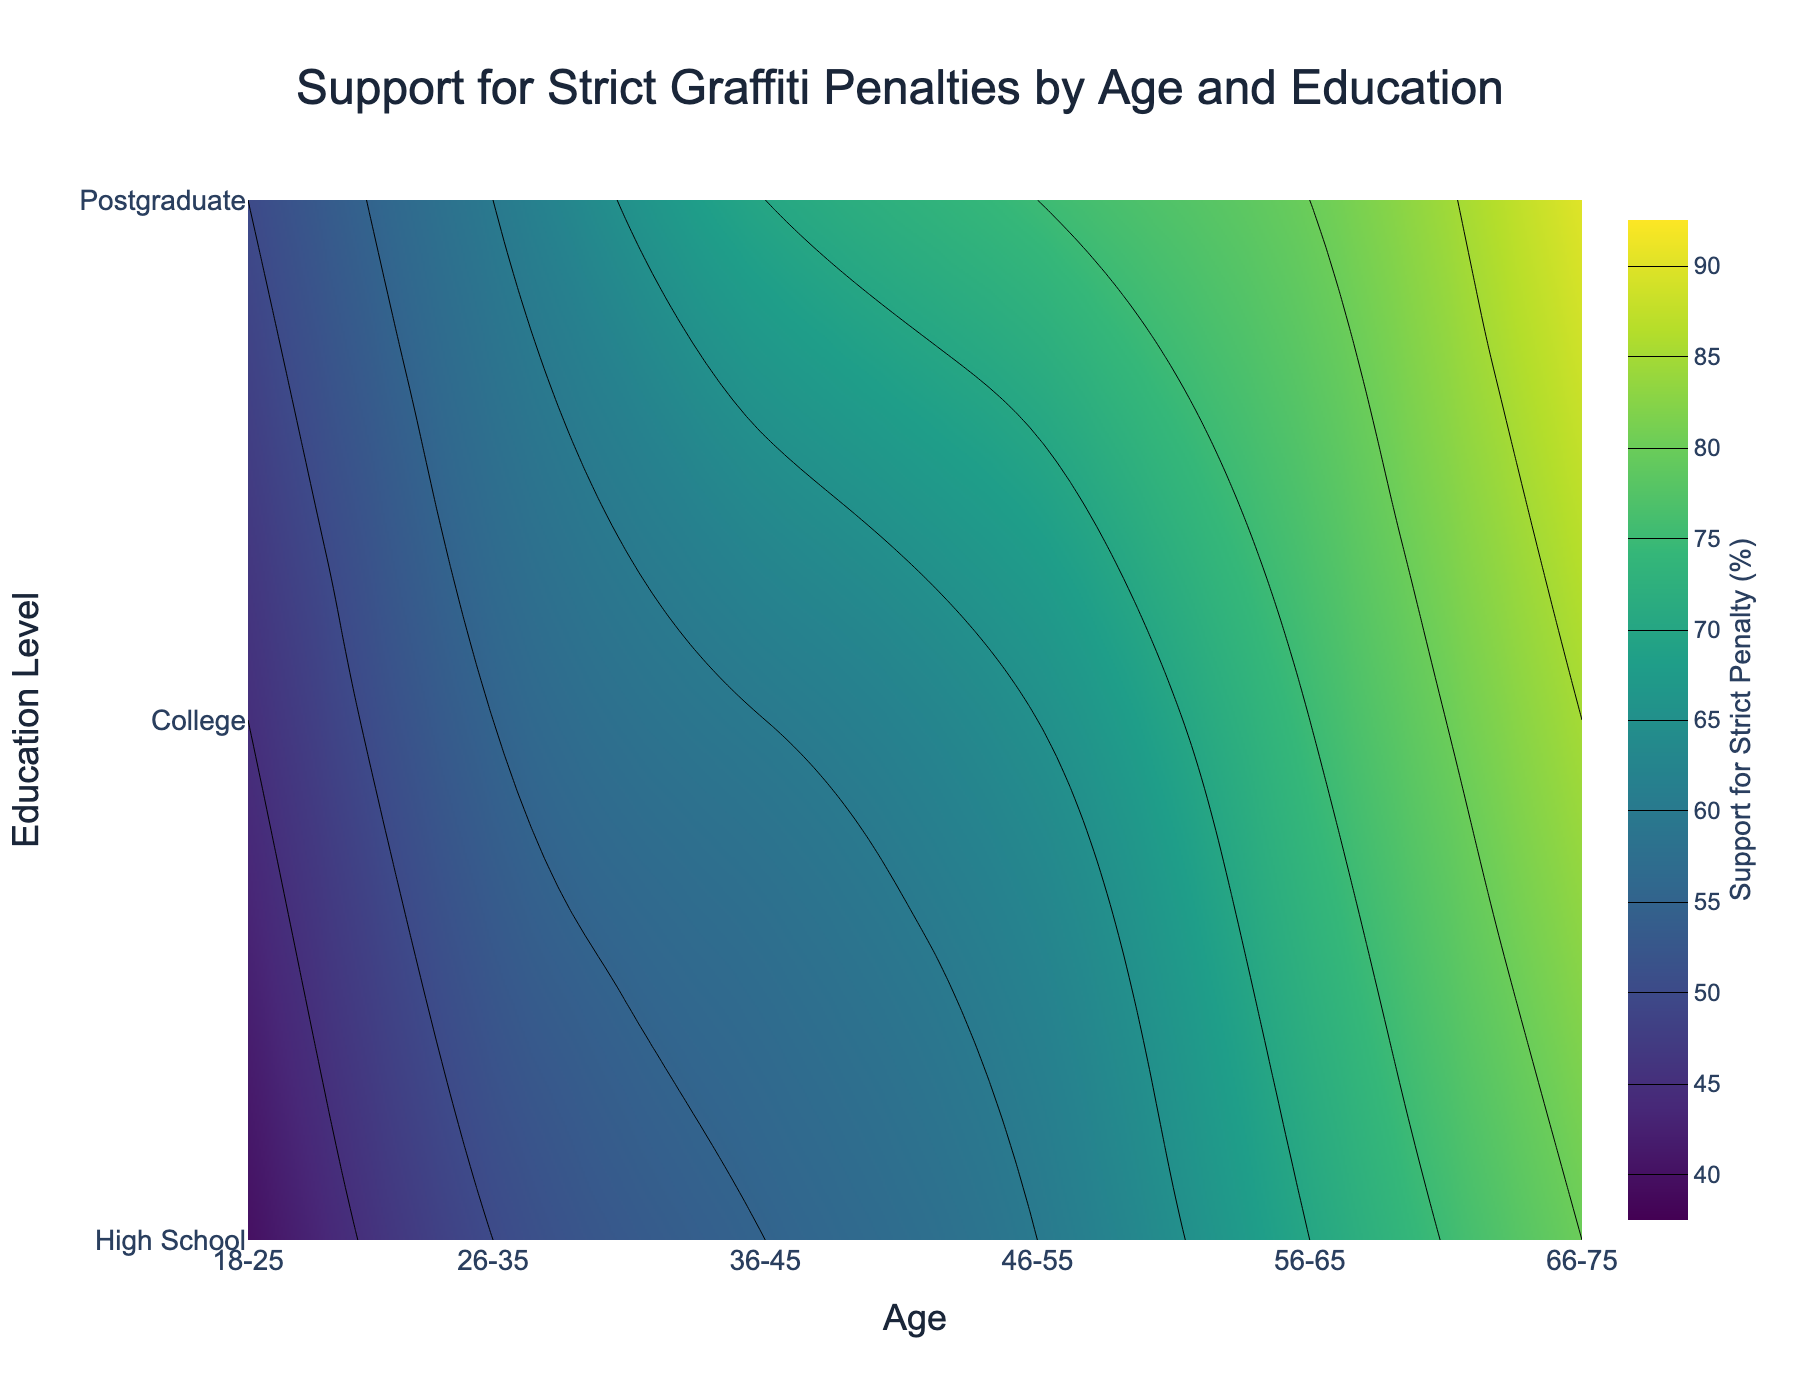What does the title of the plot say? The title is centered at the top of the plot and provides the context for understanding the data. The title text reads "Support for Strict Graffiti Penalties by Age and Education".
Answer: Support for Strict Graffiti Penalties by Age and Education What are the x and y-axis titles? The axes provide labels indicating what dimensions are represented in the contour plot. The x-axis title is "Age", and the y-axis title is "Education Level".
Answer: Age; Education Level Which age group shows the least support for strict graffiti penalties at the High School education level? Observing the contour areas on the left side of the plot, the least support for strict penalties at the High School education level is indicated as the lowest value, present in the age group 18-25.
Answer: 18-25 How does support for strict graffiti penalties change with age at the College education level? Following the contour lines upwards (y=2) as age increases on the x-axis, the contour lines indicate an increase in support percentages. Thus, support for strict penalties generally increases with age at the College education level.
Answer: Increases Compare the support for strict penalties between individuals aged 56-65 with a Postgraduate education to those aged 26-35 with a High School education. Locate the two intersection points on the contour lines: 56-65/Postgraduate and 26-35/High School. The corresponding values show that individuals aged 56-65 with a Postgraduate education show higher support compared to individuals aged 26-35 with a High School education.
Answer: 80 vs. 50 What is the range of support for strict graffiti penalties across different education levels for the age group 36-45? Identify where the age group 36-45 intersects with different education levels and note the corresponding z-values (contour values). The support lies between 55% at High School and 70% at Postgraduate levels.
Answer: 55 to 70% For which age group does the support for strict penalties rise the most from High School to Postgraduate levels? Observing the contour lines across each age group and noting the difference between the lowest and highest support values within each group, the age group 66-75 shows the largest rise, from ~80% to ~90%.
Answer: 66-75 What color range indicates the highest level of support for strict graffiti penalties? Examine the color scale bar on the right side of the plot. The highest support values are represented by the darkest colors (dark green to yellow).
Answer: Dark green to yellow 